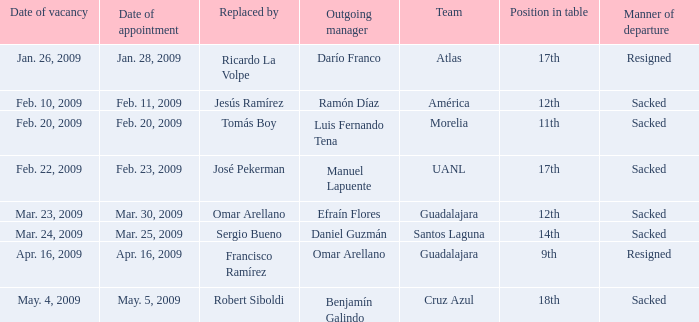What is Position in Table, when Replaced By is "Sergio Bueno"? 14th. 